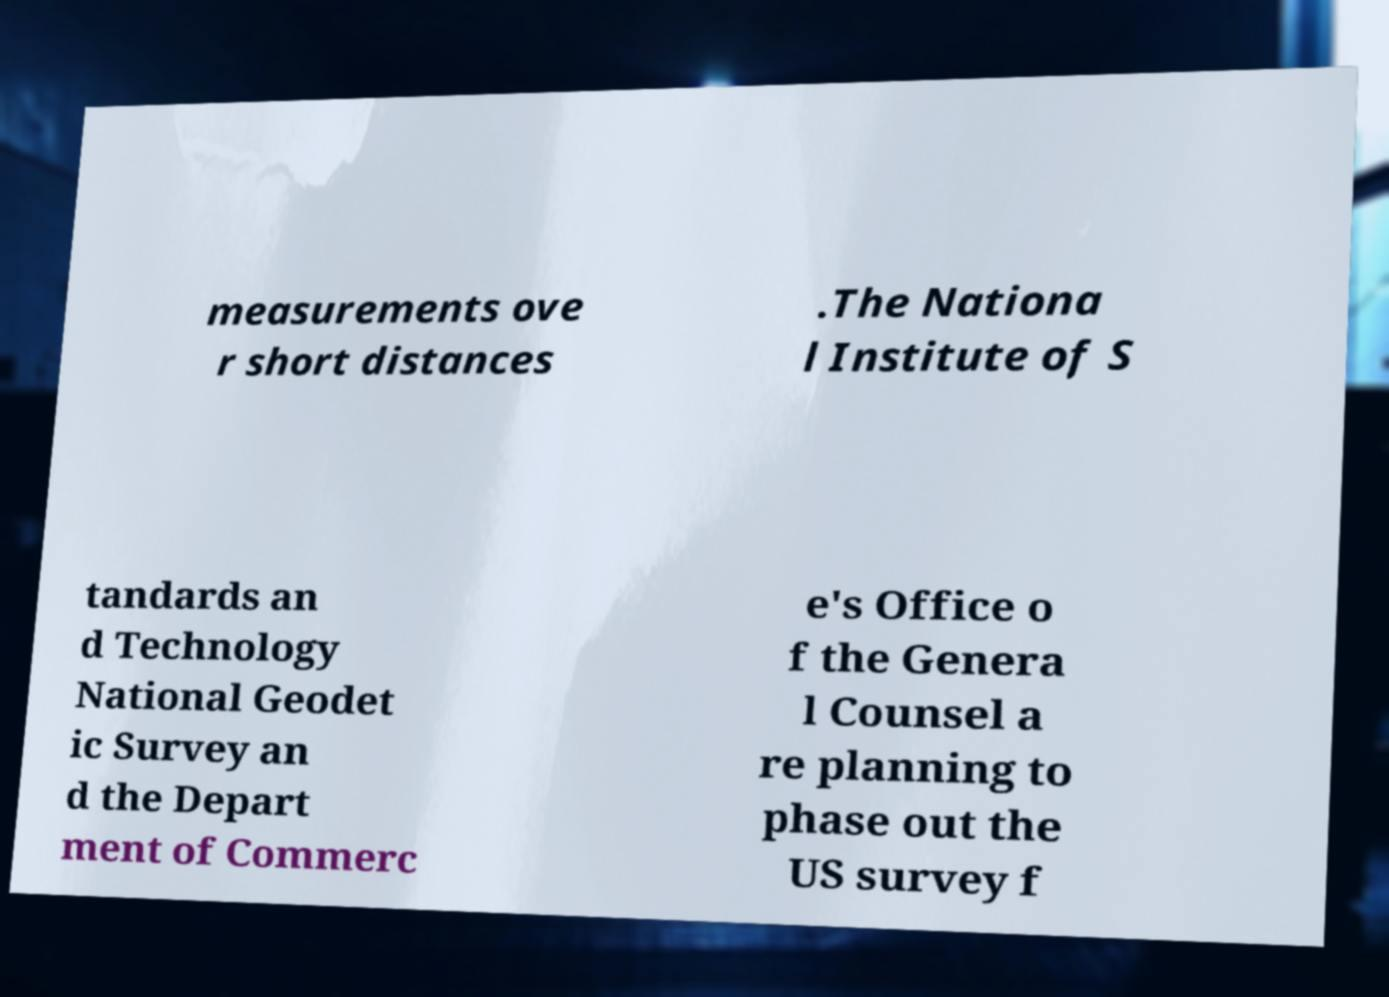Could you assist in decoding the text presented in this image and type it out clearly? measurements ove r short distances .The Nationa l Institute of S tandards an d Technology National Geodet ic Survey an d the Depart ment of Commerc e's Office o f the Genera l Counsel a re planning to phase out the US survey f 